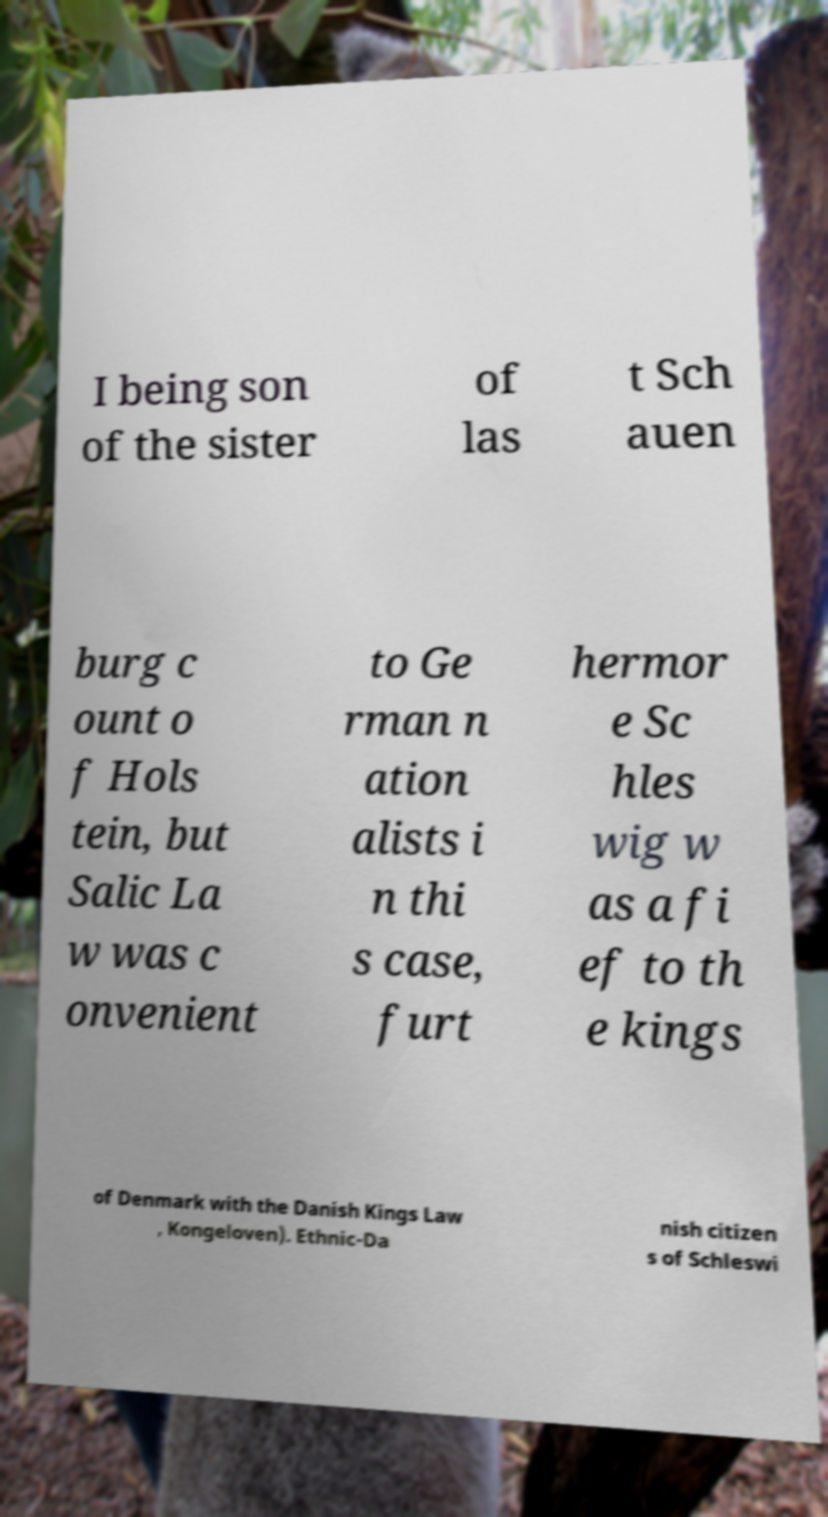Please read and relay the text visible in this image. What does it say? I being son of the sister of las t Sch auen burg c ount o f Hols tein, but Salic La w was c onvenient to Ge rman n ation alists i n thi s case, furt hermor e Sc hles wig w as a fi ef to th e kings of Denmark with the Danish Kings Law , Kongeloven). Ethnic-Da nish citizen s of Schleswi 